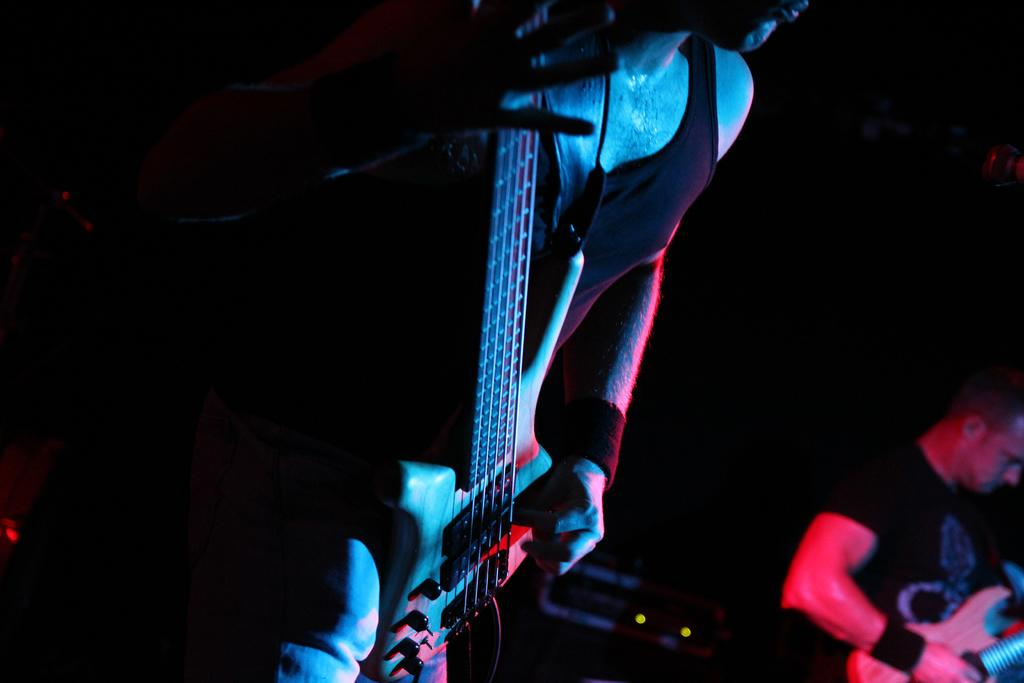How many people are in the image? There are two people in the image. What are the people holding in the image? Both people are holding guitars. What arithmetic problem are the people solving together in the image? There is no arithmetic problem present in the image; the people are holding guitars. What do the people in the image believe in? The image does not provide any information about the beliefs of the people in the image. 